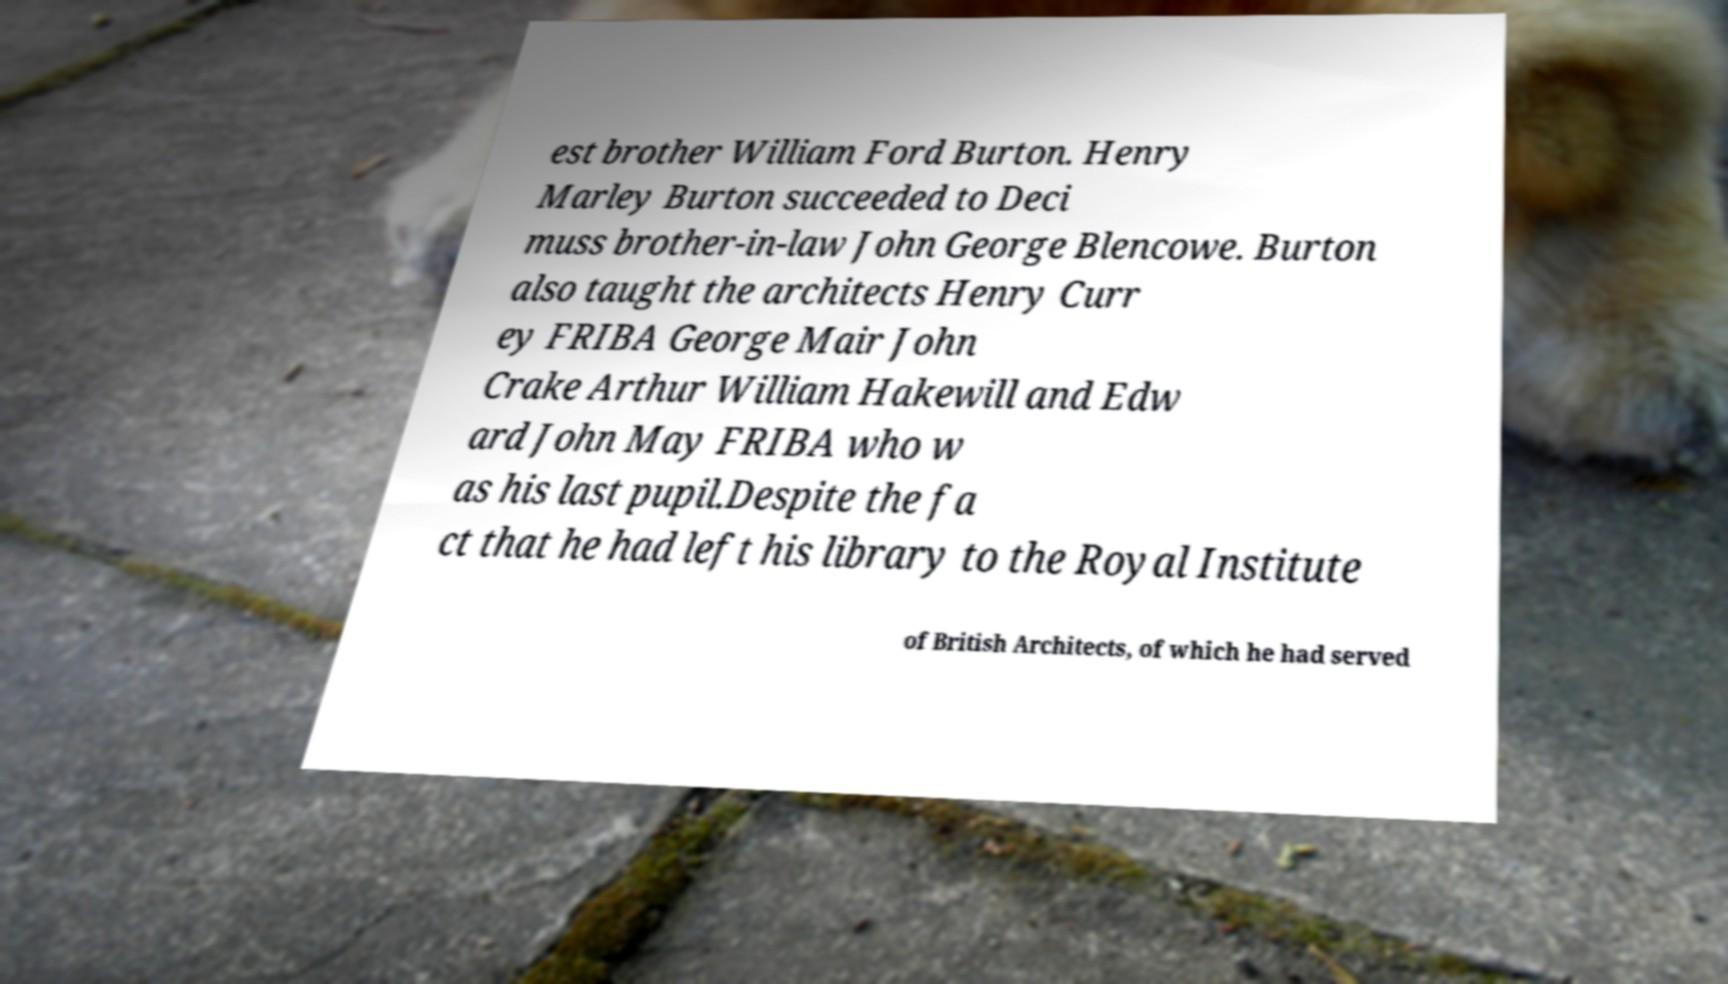Can you accurately transcribe the text from the provided image for me? est brother William Ford Burton. Henry Marley Burton succeeded to Deci muss brother-in-law John George Blencowe. Burton also taught the architects Henry Curr ey FRIBA George Mair John Crake Arthur William Hakewill and Edw ard John May FRIBA who w as his last pupil.Despite the fa ct that he had left his library to the Royal Institute of British Architects, of which he had served 